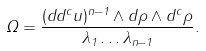Convert formula to latex. <formula><loc_0><loc_0><loc_500><loc_500>\Omega = \frac { ( d d ^ { c } u ) ^ { n - 1 } \wedge d \rho \wedge d ^ { c } \rho } { \lambda _ { 1 } \dots \lambda _ { n - 1 } } .</formula> 